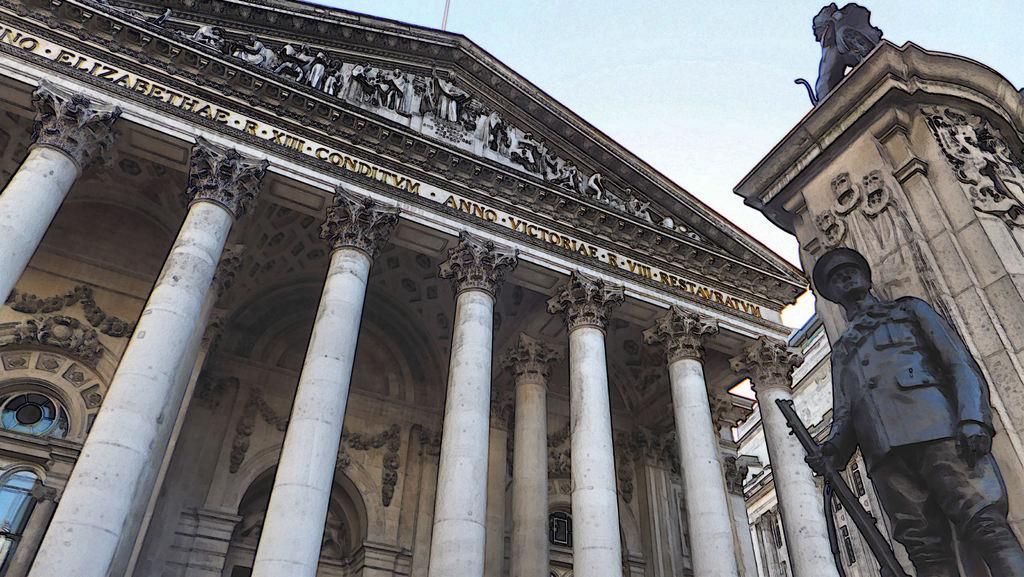What can be said about the nature of the image? The image is edited. What type of structures can be seen in the image? There are buildings in the image. What is the purpose of the name board in the image? The name board in the image is likely used for identification or direction. What type of artwork is present on the wall in the image? There are sculptures on the wall in the image. What type of figure is present in the image? There is a statue in the image. What can be seen in the sky in the image? The sky with clouds is visible in the image. How many cacti are present in the image? There are no cacti present in the image. What time of day is depicted in the image? The time of day cannot be determined from the image, as there is no specific indication of day or night. 